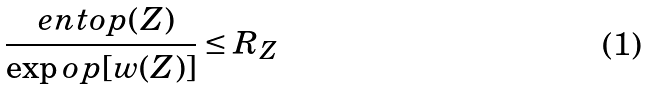Convert formula to latex. <formula><loc_0><loc_0><loc_500><loc_500>\frac { \ e n t o p ( Z ) } { \exp o p [ w ( Z ) ] } \leq R _ { Z }</formula> 